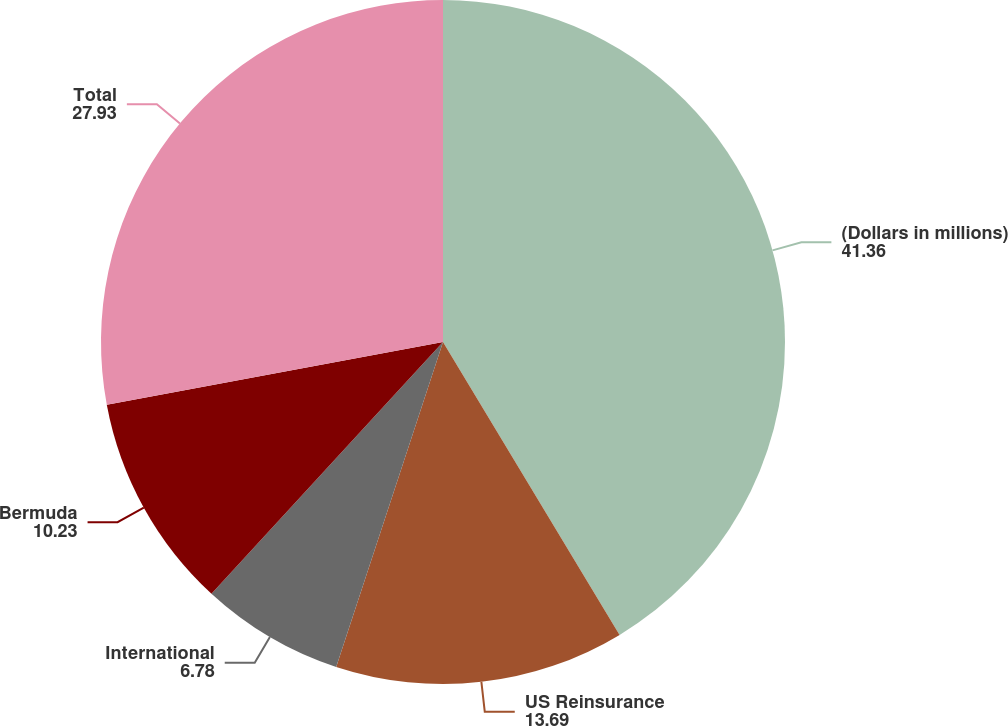<chart> <loc_0><loc_0><loc_500><loc_500><pie_chart><fcel>(Dollars in millions)<fcel>US Reinsurance<fcel>International<fcel>Bermuda<fcel>Total<nl><fcel>41.36%<fcel>13.69%<fcel>6.78%<fcel>10.23%<fcel>27.93%<nl></chart> 